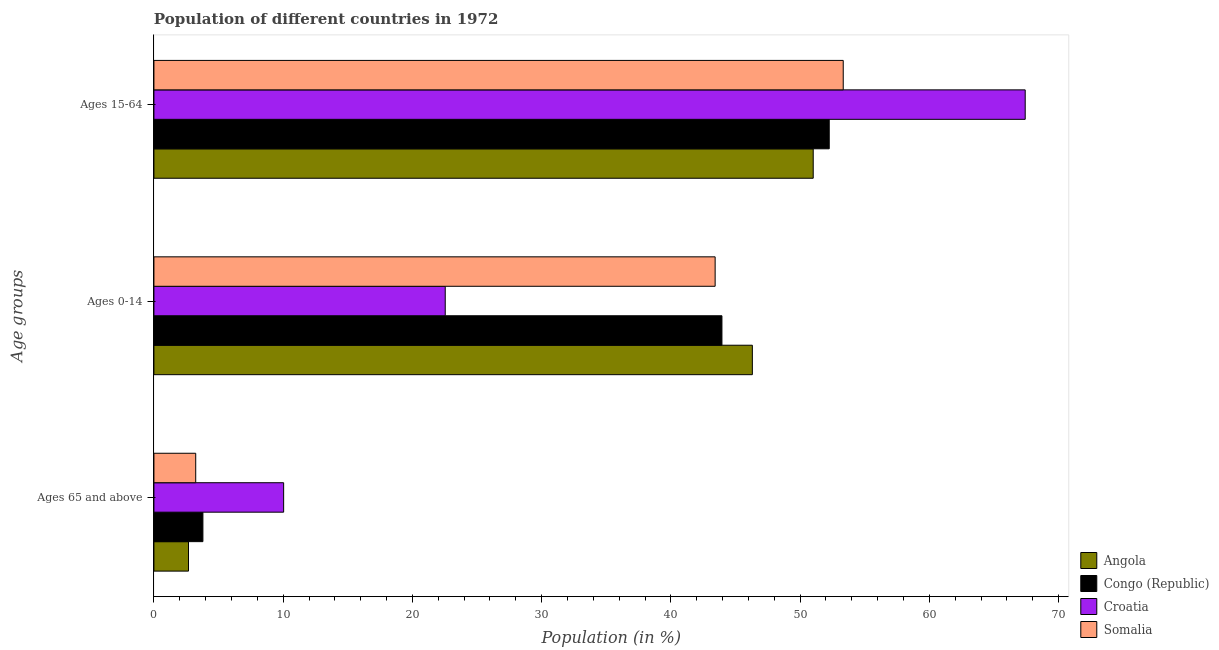Are the number of bars per tick equal to the number of legend labels?
Your answer should be very brief. Yes. How many bars are there on the 2nd tick from the top?
Give a very brief answer. 4. How many bars are there on the 1st tick from the bottom?
Your answer should be very brief. 4. What is the label of the 1st group of bars from the top?
Keep it short and to the point. Ages 15-64. What is the percentage of population within the age-group 15-64 in Somalia?
Your answer should be very brief. 53.34. Across all countries, what is the maximum percentage of population within the age-group of 65 and above?
Your answer should be compact. 10.04. Across all countries, what is the minimum percentage of population within the age-group 15-64?
Ensure brevity in your answer.  51.02. In which country was the percentage of population within the age-group 0-14 maximum?
Give a very brief answer. Angola. In which country was the percentage of population within the age-group 15-64 minimum?
Keep it short and to the point. Angola. What is the total percentage of population within the age-group 0-14 in the graph?
Offer a very short reply. 156.23. What is the difference between the percentage of population within the age-group 0-14 in Angola and that in Croatia?
Ensure brevity in your answer.  23.77. What is the difference between the percentage of population within the age-group 0-14 in Croatia and the percentage of population within the age-group 15-64 in Angola?
Offer a terse response. -28.48. What is the average percentage of population within the age-group 0-14 per country?
Make the answer very short. 39.06. What is the difference between the percentage of population within the age-group 15-64 and percentage of population within the age-group of 65 and above in Angola?
Your answer should be compact. 48.34. In how many countries, is the percentage of population within the age-group 15-64 greater than 38 %?
Offer a very short reply. 4. What is the ratio of the percentage of population within the age-group of 65 and above in Congo (Republic) to that in Croatia?
Offer a terse response. 0.38. Is the difference between the percentage of population within the age-group of 65 and above in Congo (Republic) and Angola greater than the difference between the percentage of population within the age-group 15-64 in Congo (Republic) and Angola?
Offer a terse response. No. What is the difference between the highest and the second highest percentage of population within the age-group 15-64?
Make the answer very short. 14.08. What is the difference between the highest and the lowest percentage of population within the age-group 15-64?
Your response must be concise. 16.4. In how many countries, is the percentage of population within the age-group 0-14 greater than the average percentage of population within the age-group 0-14 taken over all countries?
Your answer should be very brief. 3. What does the 1st bar from the top in Ages 65 and above represents?
Offer a terse response. Somalia. What does the 2nd bar from the bottom in Ages 65 and above represents?
Your answer should be very brief. Congo (Republic). How many bars are there?
Provide a succinct answer. 12. Are all the bars in the graph horizontal?
Your answer should be very brief. Yes. What is the difference between two consecutive major ticks on the X-axis?
Your answer should be compact. 10. Are the values on the major ticks of X-axis written in scientific E-notation?
Offer a very short reply. No. Does the graph contain any zero values?
Your response must be concise. No. How many legend labels are there?
Provide a short and direct response. 4. What is the title of the graph?
Offer a terse response. Population of different countries in 1972. Does "Malaysia" appear as one of the legend labels in the graph?
Offer a very short reply. No. What is the label or title of the Y-axis?
Your answer should be compact. Age groups. What is the Population (in %) of Angola in Ages 65 and above?
Offer a terse response. 2.68. What is the Population (in %) in Congo (Republic) in Ages 65 and above?
Keep it short and to the point. 3.79. What is the Population (in %) in Croatia in Ages 65 and above?
Your response must be concise. 10.04. What is the Population (in %) of Somalia in Ages 65 and above?
Provide a short and direct response. 3.23. What is the Population (in %) in Angola in Ages 0-14?
Your response must be concise. 46.31. What is the Population (in %) of Congo (Republic) in Ages 0-14?
Offer a very short reply. 43.95. What is the Population (in %) in Croatia in Ages 0-14?
Ensure brevity in your answer.  22.54. What is the Population (in %) of Somalia in Ages 0-14?
Your answer should be compact. 43.43. What is the Population (in %) in Angola in Ages 15-64?
Make the answer very short. 51.02. What is the Population (in %) in Congo (Republic) in Ages 15-64?
Your answer should be very brief. 52.26. What is the Population (in %) of Croatia in Ages 15-64?
Offer a terse response. 67.42. What is the Population (in %) of Somalia in Ages 15-64?
Offer a very short reply. 53.34. Across all Age groups, what is the maximum Population (in %) in Angola?
Offer a terse response. 51.02. Across all Age groups, what is the maximum Population (in %) of Congo (Republic)?
Make the answer very short. 52.26. Across all Age groups, what is the maximum Population (in %) of Croatia?
Provide a short and direct response. 67.42. Across all Age groups, what is the maximum Population (in %) of Somalia?
Make the answer very short. 53.34. Across all Age groups, what is the minimum Population (in %) of Angola?
Your answer should be very brief. 2.68. Across all Age groups, what is the minimum Population (in %) in Congo (Republic)?
Your response must be concise. 3.79. Across all Age groups, what is the minimum Population (in %) in Croatia?
Give a very brief answer. 10.04. Across all Age groups, what is the minimum Population (in %) of Somalia?
Your answer should be very brief. 3.23. What is the total Population (in %) in Angola in the graph?
Your answer should be very brief. 100. What is the difference between the Population (in %) in Angola in Ages 65 and above and that in Ages 0-14?
Provide a succinct answer. -43.63. What is the difference between the Population (in %) of Congo (Republic) in Ages 65 and above and that in Ages 0-14?
Offer a very short reply. -40.16. What is the difference between the Population (in %) in Croatia in Ages 65 and above and that in Ages 0-14?
Your answer should be compact. -12.5. What is the difference between the Population (in %) of Somalia in Ages 65 and above and that in Ages 0-14?
Provide a succinct answer. -40.19. What is the difference between the Population (in %) of Angola in Ages 65 and above and that in Ages 15-64?
Keep it short and to the point. -48.34. What is the difference between the Population (in %) in Congo (Republic) in Ages 65 and above and that in Ages 15-64?
Ensure brevity in your answer.  -48.47. What is the difference between the Population (in %) in Croatia in Ages 65 and above and that in Ages 15-64?
Give a very brief answer. -57.38. What is the difference between the Population (in %) of Somalia in Ages 65 and above and that in Ages 15-64?
Make the answer very short. -50.11. What is the difference between the Population (in %) in Angola in Ages 0-14 and that in Ages 15-64?
Your answer should be very brief. -4.71. What is the difference between the Population (in %) in Congo (Republic) in Ages 0-14 and that in Ages 15-64?
Your answer should be compact. -8.3. What is the difference between the Population (in %) of Croatia in Ages 0-14 and that in Ages 15-64?
Your response must be concise. -44.88. What is the difference between the Population (in %) in Somalia in Ages 0-14 and that in Ages 15-64?
Make the answer very short. -9.91. What is the difference between the Population (in %) in Angola in Ages 65 and above and the Population (in %) in Congo (Republic) in Ages 0-14?
Make the answer very short. -41.28. What is the difference between the Population (in %) in Angola in Ages 65 and above and the Population (in %) in Croatia in Ages 0-14?
Keep it short and to the point. -19.87. What is the difference between the Population (in %) of Angola in Ages 65 and above and the Population (in %) of Somalia in Ages 0-14?
Make the answer very short. -40.75. What is the difference between the Population (in %) of Congo (Republic) in Ages 65 and above and the Population (in %) of Croatia in Ages 0-14?
Offer a terse response. -18.75. What is the difference between the Population (in %) of Congo (Republic) in Ages 65 and above and the Population (in %) of Somalia in Ages 0-14?
Provide a succinct answer. -39.64. What is the difference between the Population (in %) of Croatia in Ages 65 and above and the Population (in %) of Somalia in Ages 0-14?
Your response must be concise. -33.39. What is the difference between the Population (in %) of Angola in Ages 65 and above and the Population (in %) of Congo (Republic) in Ages 15-64?
Keep it short and to the point. -49.58. What is the difference between the Population (in %) in Angola in Ages 65 and above and the Population (in %) in Croatia in Ages 15-64?
Your answer should be compact. -64.75. What is the difference between the Population (in %) of Angola in Ages 65 and above and the Population (in %) of Somalia in Ages 15-64?
Make the answer very short. -50.66. What is the difference between the Population (in %) of Congo (Republic) in Ages 65 and above and the Population (in %) of Croatia in Ages 15-64?
Make the answer very short. -63.63. What is the difference between the Population (in %) in Congo (Republic) in Ages 65 and above and the Population (in %) in Somalia in Ages 15-64?
Offer a terse response. -49.55. What is the difference between the Population (in %) of Croatia in Ages 65 and above and the Population (in %) of Somalia in Ages 15-64?
Ensure brevity in your answer.  -43.3. What is the difference between the Population (in %) in Angola in Ages 0-14 and the Population (in %) in Congo (Republic) in Ages 15-64?
Ensure brevity in your answer.  -5.95. What is the difference between the Population (in %) of Angola in Ages 0-14 and the Population (in %) of Croatia in Ages 15-64?
Provide a short and direct response. -21.11. What is the difference between the Population (in %) of Angola in Ages 0-14 and the Population (in %) of Somalia in Ages 15-64?
Give a very brief answer. -7.03. What is the difference between the Population (in %) of Congo (Republic) in Ages 0-14 and the Population (in %) of Croatia in Ages 15-64?
Give a very brief answer. -23.47. What is the difference between the Population (in %) in Congo (Republic) in Ages 0-14 and the Population (in %) in Somalia in Ages 15-64?
Your answer should be very brief. -9.39. What is the difference between the Population (in %) in Croatia in Ages 0-14 and the Population (in %) in Somalia in Ages 15-64?
Provide a succinct answer. -30.8. What is the average Population (in %) in Angola per Age groups?
Keep it short and to the point. 33.33. What is the average Population (in %) of Congo (Republic) per Age groups?
Make the answer very short. 33.33. What is the average Population (in %) in Croatia per Age groups?
Your answer should be very brief. 33.33. What is the average Population (in %) in Somalia per Age groups?
Provide a short and direct response. 33.33. What is the difference between the Population (in %) of Angola and Population (in %) of Congo (Republic) in Ages 65 and above?
Offer a terse response. -1.11. What is the difference between the Population (in %) in Angola and Population (in %) in Croatia in Ages 65 and above?
Give a very brief answer. -7.36. What is the difference between the Population (in %) of Angola and Population (in %) of Somalia in Ages 65 and above?
Your answer should be very brief. -0.56. What is the difference between the Population (in %) in Congo (Republic) and Population (in %) in Croatia in Ages 65 and above?
Offer a very short reply. -6.25. What is the difference between the Population (in %) in Congo (Republic) and Population (in %) in Somalia in Ages 65 and above?
Give a very brief answer. 0.56. What is the difference between the Population (in %) in Croatia and Population (in %) in Somalia in Ages 65 and above?
Ensure brevity in your answer.  6.8. What is the difference between the Population (in %) in Angola and Population (in %) in Congo (Republic) in Ages 0-14?
Your answer should be very brief. 2.35. What is the difference between the Population (in %) of Angola and Population (in %) of Croatia in Ages 0-14?
Provide a short and direct response. 23.77. What is the difference between the Population (in %) of Angola and Population (in %) of Somalia in Ages 0-14?
Offer a terse response. 2.88. What is the difference between the Population (in %) in Congo (Republic) and Population (in %) in Croatia in Ages 0-14?
Offer a very short reply. 21.41. What is the difference between the Population (in %) in Congo (Republic) and Population (in %) in Somalia in Ages 0-14?
Keep it short and to the point. 0.53. What is the difference between the Population (in %) in Croatia and Population (in %) in Somalia in Ages 0-14?
Make the answer very short. -20.89. What is the difference between the Population (in %) of Angola and Population (in %) of Congo (Republic) in Ages 15-64?
Make the answer very short. -1.24. What is the difference between the Population (in %) in Angola and Population (in %) in Croatia in Ages 15-64?
Keep it short and to the point. -16.4. What is the difference between the Population (in %) in Angola and Population (in %) in Somalia in Ages 15-64?
Make the answer very short. -2.32. What is the difference between the Population (in %) in Congo (Republic) and Population (in %) in Croatia in Ages 15-64?
Ensure brevity in your answer.  -15.16. What is the difference between the Population (in %) in Congo (Republic) and Population (in %) in Somalia in Ages 15-64?
Provide a succinct answer. -1.08. What is the difference between the Population (in %) of Croatia and Population (in %) of Somalia in Ages 15-64?
Offer a very short reply. 14.08. What is the ratio of the Population (in %) of Angola in Ages 65 and above to that in Ages 0-14?
Your response must be concise. 0.06. What is the ratio of the Population (in %) of Congo (Republic) in Ages 65 and above to that in Ages 0-14?
Your answer should be compact. 0.09. What is the ratio of the Population (in %) in Croatia in Ages 65 and above to that in Ages 0-14?
Keep it short and to the point. 0.45. What is the ratio of the Population (in %) in Somalia in Ages 65 and above to that in Ages 0-14?
Give a very brief answer. 0.07. What is the ratio of the Population (in %) of Angola in Ages 65 and above to that in Ages 15-64?
Your answer should be very brief. 0.05. What is the ratio of the Population (in %) in Congo (Republic) in Ages 65 and above to that in Ages 15-64?
Offer a very short reply. 0.07. What is the ratio of the Population (in %) of Croatia in Ages 65 and above to that in Ages 15-64?
Provide a short and direct response. 0.15. What is the ratio of the Population (in %) in Somalia in Ages 65 and above to that in Ages 15-64?
Offer a very short reply. 0.06. What is the ratio of the Population (in %) in Angola in Ages 0-14 to that in Ages 15-64?
Offer a very short reply. 0.91. What is the ratio of the Population (in %) of Congo (Republic) in Ages 0-14 to that in Ages 15-64?
Provide a succinct answer. 0.84. What is the ratio of the Population (in %) in Croatia in Ages 0-14 to that in Ages 15-64?
Ensure brevity in your answer.  0.33. What is the ratio of the Population (in %) of Somalia in Ages 0-14 to that in Ages 15-64?
Your response must be concise. 0.81. What is the difference between the highest and the second highest Population (in %) in Angola?
Your response must be concise. 4.71. What is the difference between the highest and the second highest Population (in %) in Congo (Republic)?
Ensure brevity in your answer.  8.3. What is the difference between the highest and the second highest Population (in %) in Croatia?
Keep it short and to the point. 44.88. What is the difference between the highest and the second highest Population (in %) in Somalia?
Offer a very short reply. 9.91. What is the difference between the highest and the lowest Population (in %) in Angola?
Provide a short and direct response. 48.34. What is the difference between the highest and the lowest Population (in %) in Congo (Republic)?
Your answer should be compact. 48.47. What is the difference between the highest and the lowest Population (in %) of Croatia?
Your response must be concise. 57.38. What is the difference between the highest and the lowest Population (in %) of Somalia?
Give a very brief answer. 50.11. 